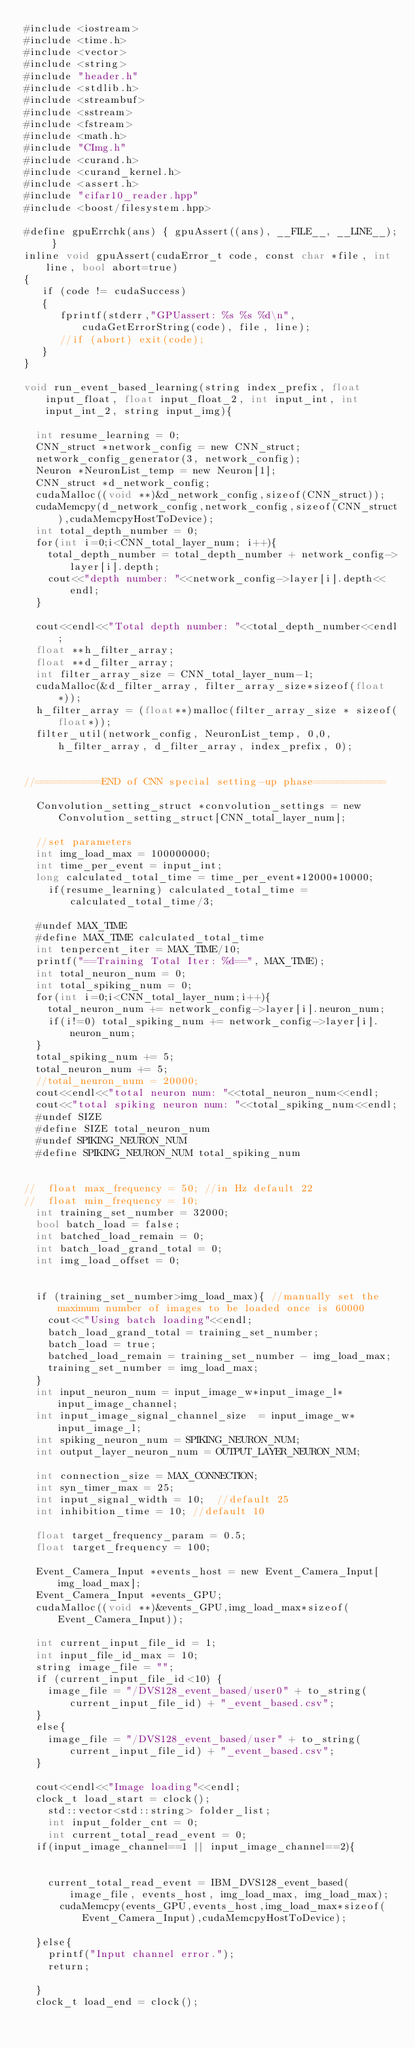Convert code to text. <code><loc_0><loc_0><loc_500><loc_500><_Cuda_>#include <iostream>
#include <time.h>
#include <vector>
#include <string>
#include "header.h"
#include <stdlib.h>
#include <streambuf>
#include <sstream>
#include <fstream>
#include <math.h>
#include "CImg.h"
#include <curand.h>
#include <curand_kernel.h>
#include <assert.h>
#include "cifar10_reader.hpp"
#include <boost/filesystem.hpp>

#define gpuErrchk(ans) { gpuAssert((ans), __FILE__, __LINE__); }
inline void gpuAssert(cudaError_t code, const char *file, int line, bool abort=true)
{
   if (code != cudaSuccess)
   {
      fprintf(stderr,"GPUassert: %s %s %d\n", cudaGetErrorString(code), file, line);
      //if (abort) exit(code);
   }
}

void run_event_based_learning(string index_prefix, float input_float, float input_float_2, int input_int, int input_int_2, string input_img){

	int resume_learning = 0;
	CNN_struct *network_config = new CNN_struct;
	network_config_generator(3, network_config);
	Neuron *NeuronList_temp = new Neuron[1];
	CNN_struct *d_network_config;
	cudaMalloc((void **)&d_network_config,sizeof(CNN_struct));
	cudaMemcpy(d_network_config,network_config,sizeof(CNN_struct),cudaMemcpyHostToDevice);
	int total_depth_number = 0;
	for(int i=0;i<CNN_total_layer_num; i++){
		total_depth_number = total_depth_number + network_config->layer[i].depth;
		cout<<"depth number: "<<network_config->layer[i].depth<<endl;
	}

	cout<<endl<<"Total depth number: "<<total_depth_number<<endl;
	float **h_filter_array;
	float **d_filter_array;
	int filter_array_size = CNN_total_layer_num-1;
	cudaMalloc(&d_filter_array, filter_array_size*sizeof(float *));
	h_filter_array = (float**)malloc(filter_array_size * sizeof(float*));
	filter_util(network_config, NeuronList_temp, 0,0,  h_filter_array, d_filter_array, index_prefix, 0);


//===========END of CNN special setting-up phase============

	Convolution_setting_struct *convolution_settings = new Convolution_setting_struct[CNN_total_layer_num];

	//set parameters
	int img_load_max = 100000000;
	int time_per_event = input_int;
	long calculated_total_time = time_per_event*12000*10000;
    if(resume_learning) calculated_total_time = calculated_total_time/3;

	#undef MAX_TIME
	#define MAX_TIME calculated_total_time
	int tenpercent_iter = MAX_TIME/10;
	printf("==Training Total Iter: %d==", MAX_TIME);
	int total_neuron_num = 0;
	int total_spiking_num = 0;
	for(int i=0;i<CNN_total_layer_num;i++){
		total_neuron_num += network_config->layer[i].neuron_num;
		if(i!=0) total_spiking_num += network_config->layer[i].neuron_num;
	}
	total_spiking_num += 5;
	total_neuron_num += 5;
	//total_neuron_num = 20000;
	cout<<endl<<"total neuron num: "<<total_neuron_num<<endl;
	cout<<"total spiking neuron num: "<<total_spiking_num<<endl;
	#undef SIZE
	#define SIZE total_neuron_num
	#undef SPIKING_NEURON_NUM
	#define SPIKING_NEURON_NUM total_spiking_num


//	float max_frequency = 50; //in Hz default 22
//	float min_frequency = 10;
	int training_set_number = 32000;
	bool batch_load = false;
	int batched_load_remain = 0;
	int batch_load_grand_total = 0;
	int img_load_offset = 0;


	if (training_set_number>img_load_max){ //manually set the maximum number of images to be loaded once is 60000
		cout<<"Using batch loading"<<endl;
		batch_load_grand_total = training_set_number;
		batch_load = true;
		batched_load_remain = training_set_number - img_load_max;
		training_set_number = img_load_max;
	}
	int input_neuron_num = input_image_w*input_image_l*input_image_channel;
	int input_image_signal_channel_size  = input_image_w*input_image_l;
	int spiking_neuron_num = SPIKING_NEURON_NUM;
	int output_layer_neuron_num = OUTPUT_LAYER_NEURON_NUM;

	int connection_size = MAX_CONNECTION;
	int syn_timer_max = 25;
	int input_signal_width = 10;	//default 25
	int inhibition_time = 10;	//default 10

	float target_frequency_param = 0.5;
	float target_frequency = 100;

	Event_Camera_Input *events_host = new Event_Camera_Input[img_load_max];
	Event_Camera_Input *events_GPU;
	cudaMalloc((void **)&events_GPU,img_load_max*sizeof(Event_Camera_Input));

	int current_input_file_id = 1;
	int input_file_id_max = 10;
	string image_file = "";
	if (current_input_file_id<10) {
		image_file = "/DVS128_event_based/user0" + to_string(current_input_file_id) + "_event_based.csv";
	}
	else{
		image_file = "/DVS128_event_based/user" + to_string(current_input_file_id) + "_event_based.csv";
	}

	cout<<endl<<"Image loading"<<endl;
	clock_t load_start = clock();
    std::vector<std::string> folder_list;
    int input_folder_cnt = 0;
    int current_total_read_event = 0;
	if(input_image_channel==1 || input_image_channel==2){


		current_total_read_event = IBM_DVS128_event_based(image_file, events_host, img_load_max, img_load_max);
	    cudaMemcpy(events_GPU,events_host,img_load_max*sizeof(Event_Camera_Input),cudaMemcpyHostToDevice);

	}else{
		printf("Input channel error.");
		return;

	}
	clock_t load_end = clock();</code> 